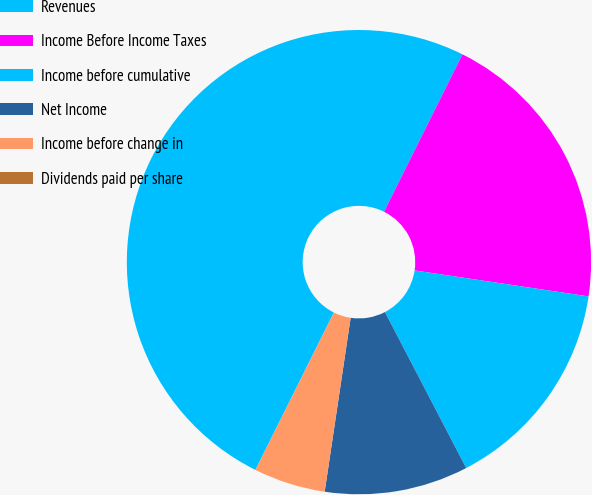<chart> <loc_0><loc_0><loc_500><loc_500><pie_chart><fcel>Revenues<fcel>Income Before Income Taxes<fcel>Income before cumulative<fcel>Net Income<fcel>Income before change in<fcel>Dividends paid per share<nl><fcel>50.0%<fcel>20.0%<fcel>15.0%<fcel>10.0%<fcel>5.0%<fcel>0.0%<nl></chart> 